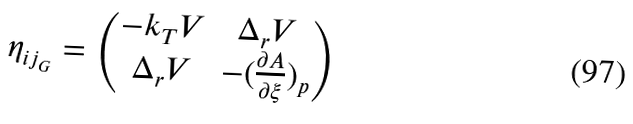<formula> <loc_0><loc_0><loc_500><loc_500>\eta _ { i j _ { G } } = \begin{pmatrix} - k _ { T } V & \Delta _ { r } V \\ \Delta _ { r } V & - ( \frac { \partial { A } } { \partial { \xi } } ) _ { p } \end{pmatrix}</formula> 